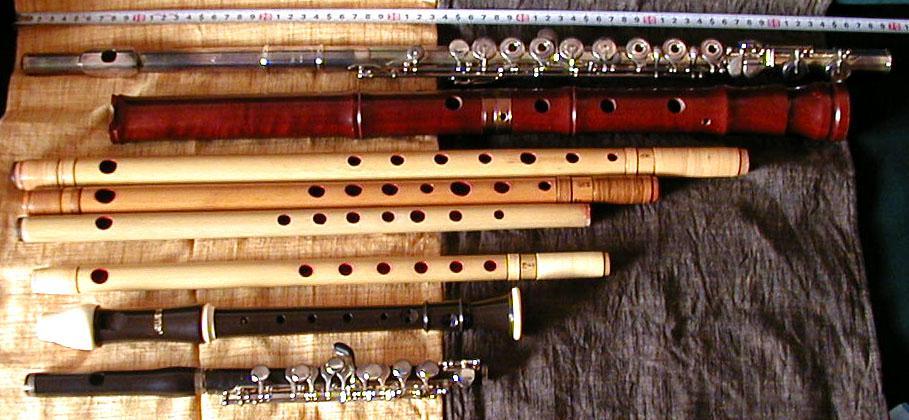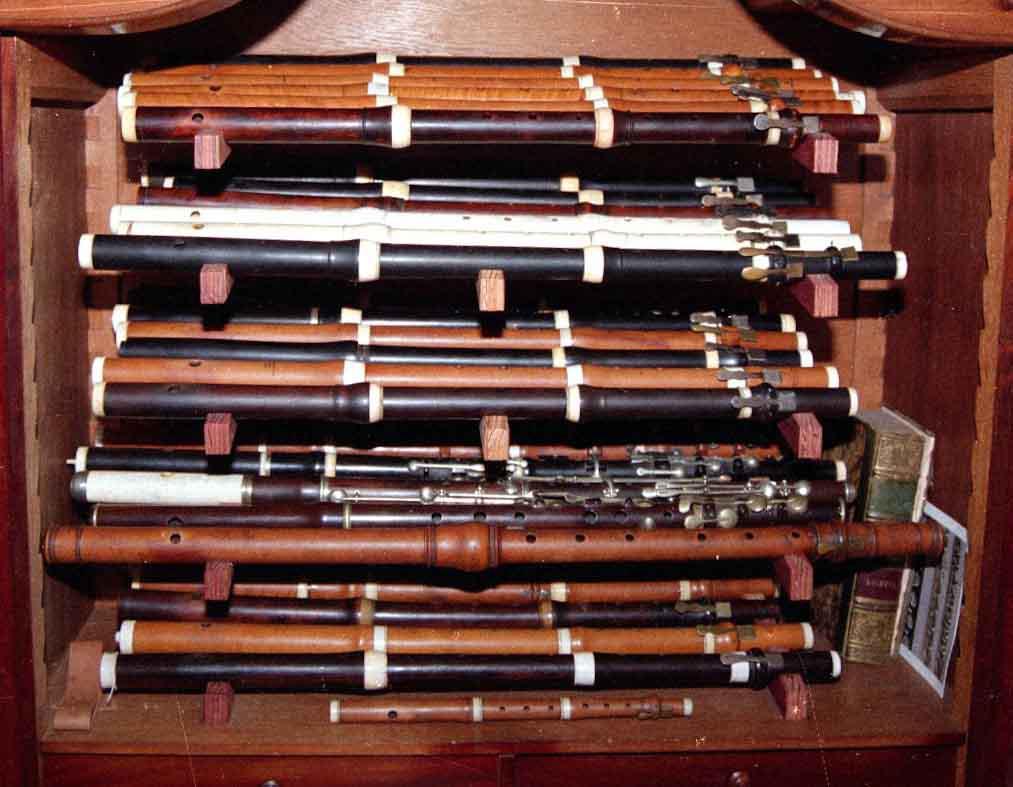The first image is the image on the left, the second image is the image on the right. Considering the images on both sides, is "An image contains various flute like instruments with an all white background." valid? Answer yes or no. No. The first image is the image on the left, the second image is the image on the right. Evaluate the accuracy of this statement regarding the images: "There are at least  15 flutes that are white, black or brown sitting on  multiple shelves.". Is it true? Answer yes or no. Yes. 